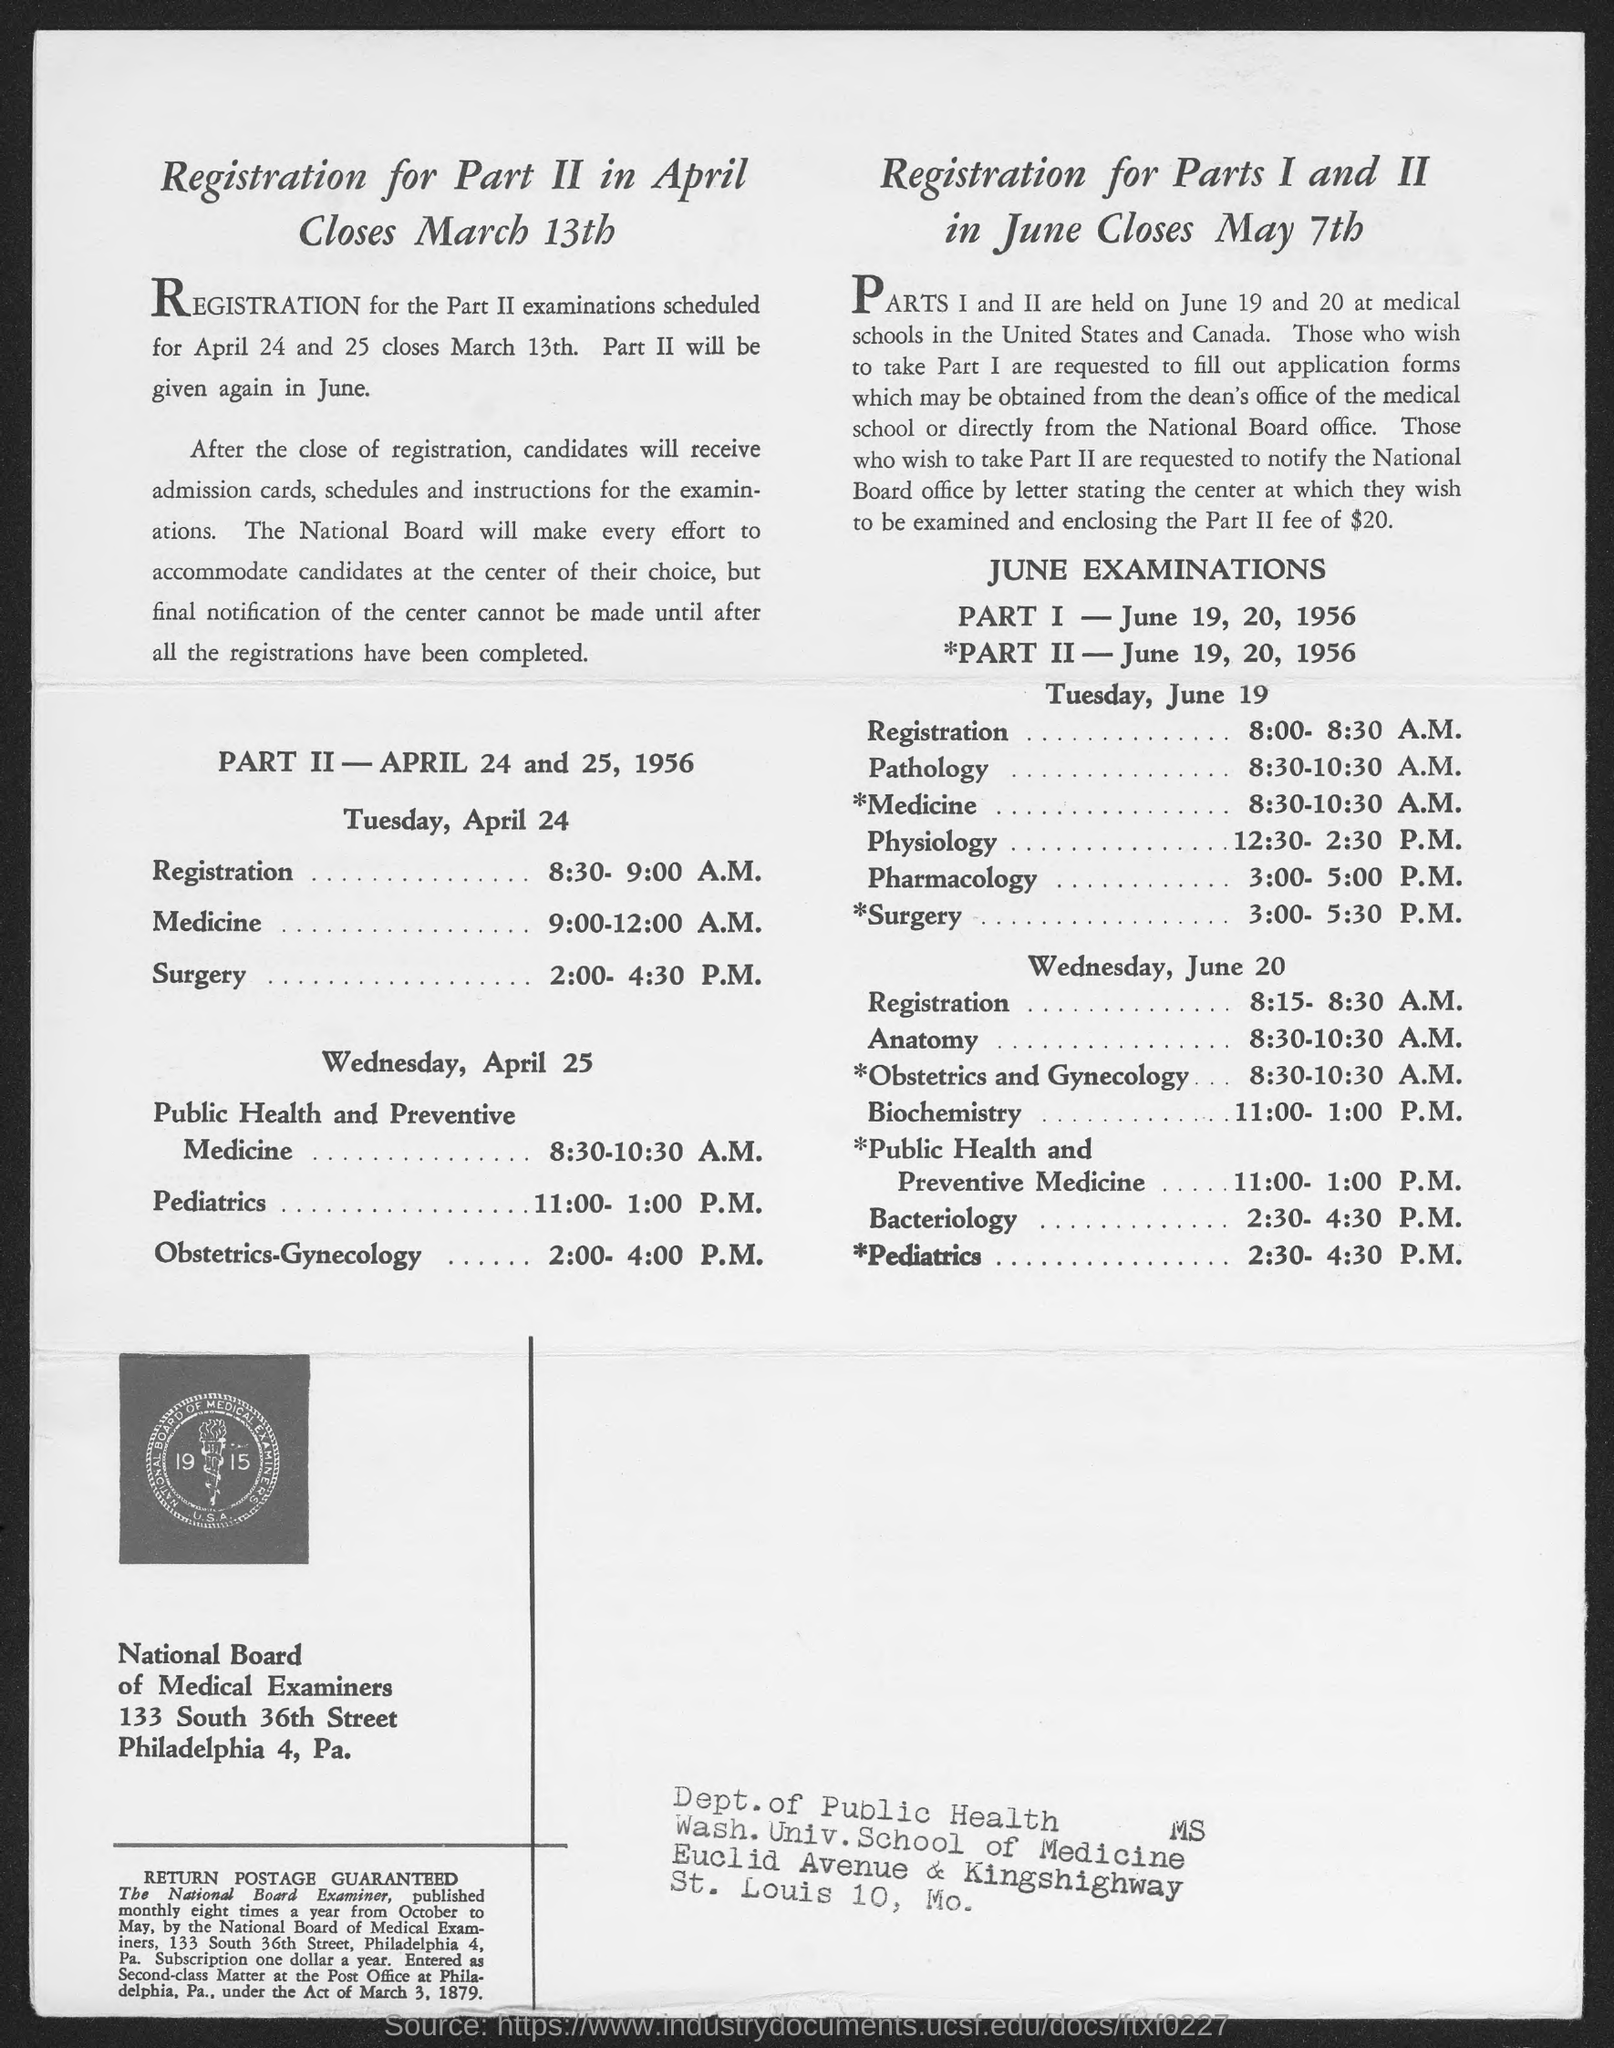When will Registration for Part II in April close?
Keep it short and to the point. March 13th. At what time is the Registration on Tuesday, April 24?
Provide a short and direct response. 8:30- 9:00 a.m. Which board is mentioned?
Keep it short and to the point. National Board of Medical Examiners. Which examination is from 3:00- 5:00 P.M. on Tuesday, June 19?
Your answer should be compact. Pharmacology. On which dates will PART I JUNE EXAMINATIONS be held?
Ensure brevity in your answer.  June 19, 20, 1956. 